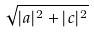Convert formula to latex. <formula><loc_0><loc_0><loc_500><loc_500>\sqrt { | a | ^ { 2 } + | c | ^ { 2 } }</formula> 